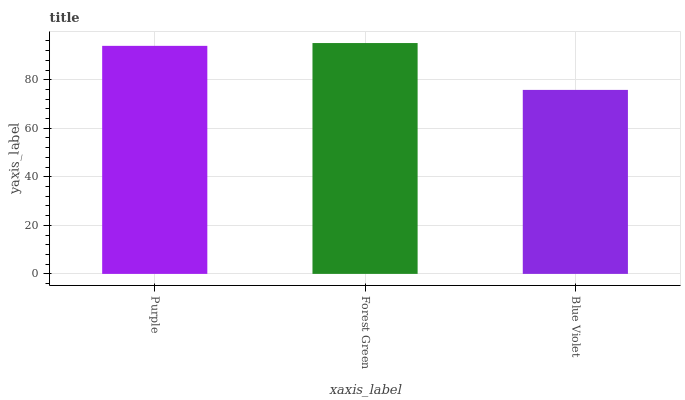Is Forest Green the minimum?
Answer yes or no. No. Is Blue Violet the maximum?
Answer yes or no. No. Is Forest Green greater than Blue Violet?
Answer yes or no. Yes. Is Blue Violet less than Forest Green?
Answer yes or no. Yes. Is Blue Violet greater than Forest Green?
Answer yes or no. No. Is Forest Green less than Blue Violet?
Answer yes or no. No. Is Purple the high median?
Answer yes or no. Yes. Is Purple the low median?
Answer yes or no. Yes. Is Forest Green the high median?
Answer yes or no. No. Is Forest Green the low median?
Answer yes or no. No. 